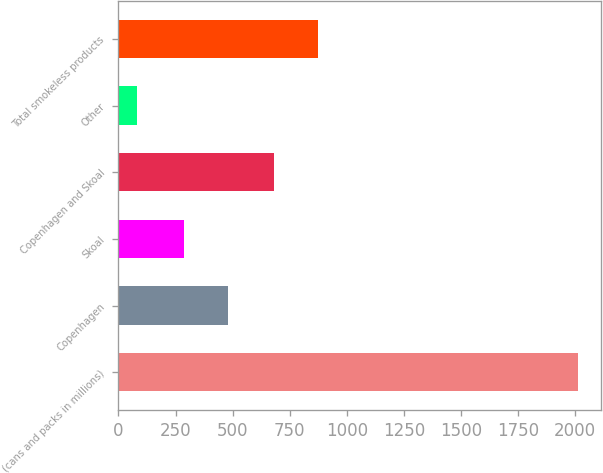Convert chart to OTSL. <chart><loc_0><loc_0><loc_500><loc_500><bar_chart><fcel>(cans and packs in millions)<fcel>Copenhagen<fcel>Skoal<fcel>Copenhagen and Skoal<fcel>Other<fcel>Total smokeless products<nl><fcel>2012<fcel>481.36<fcel>288.4<fcel>680.9<fcel>82.4<fcel>873.86<nl></chart> 